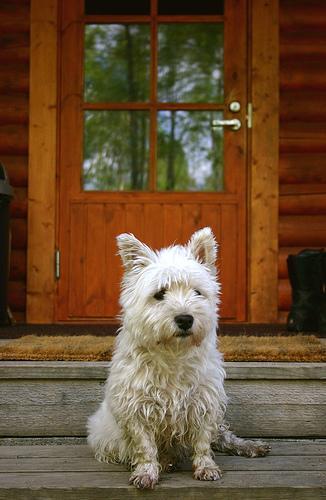How many animals are in the photo?
Give a very brief answer. 1. 